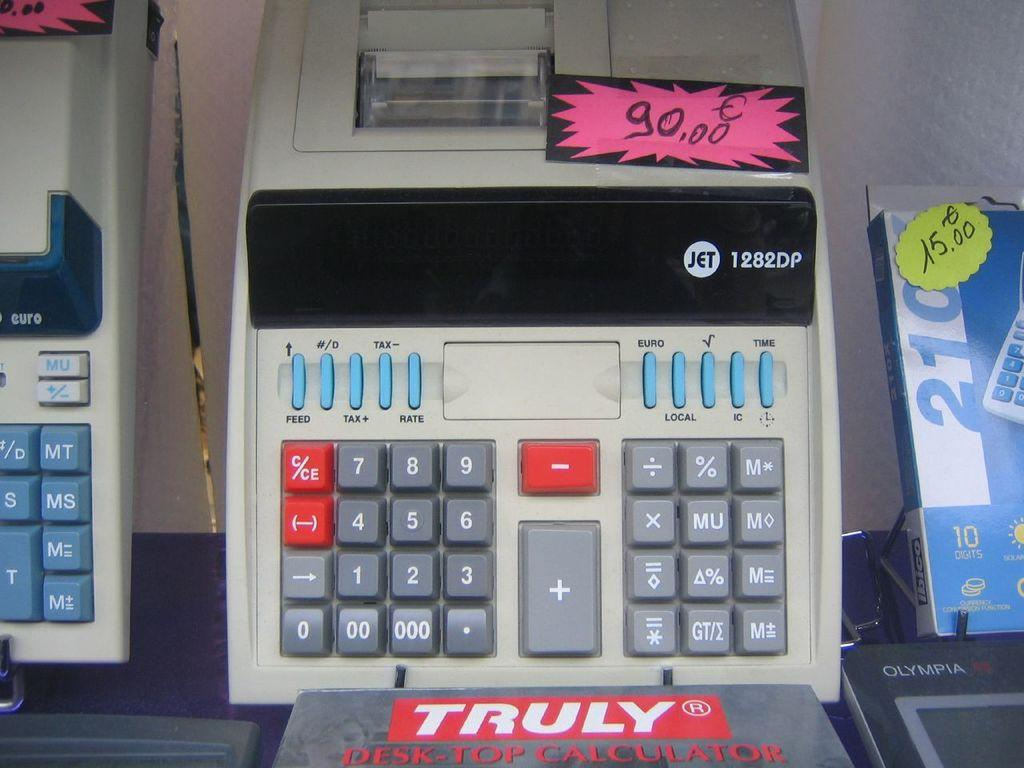<image>
Present a compact description of the photo's key features. A Truly desk top calculator with a price tag on it 